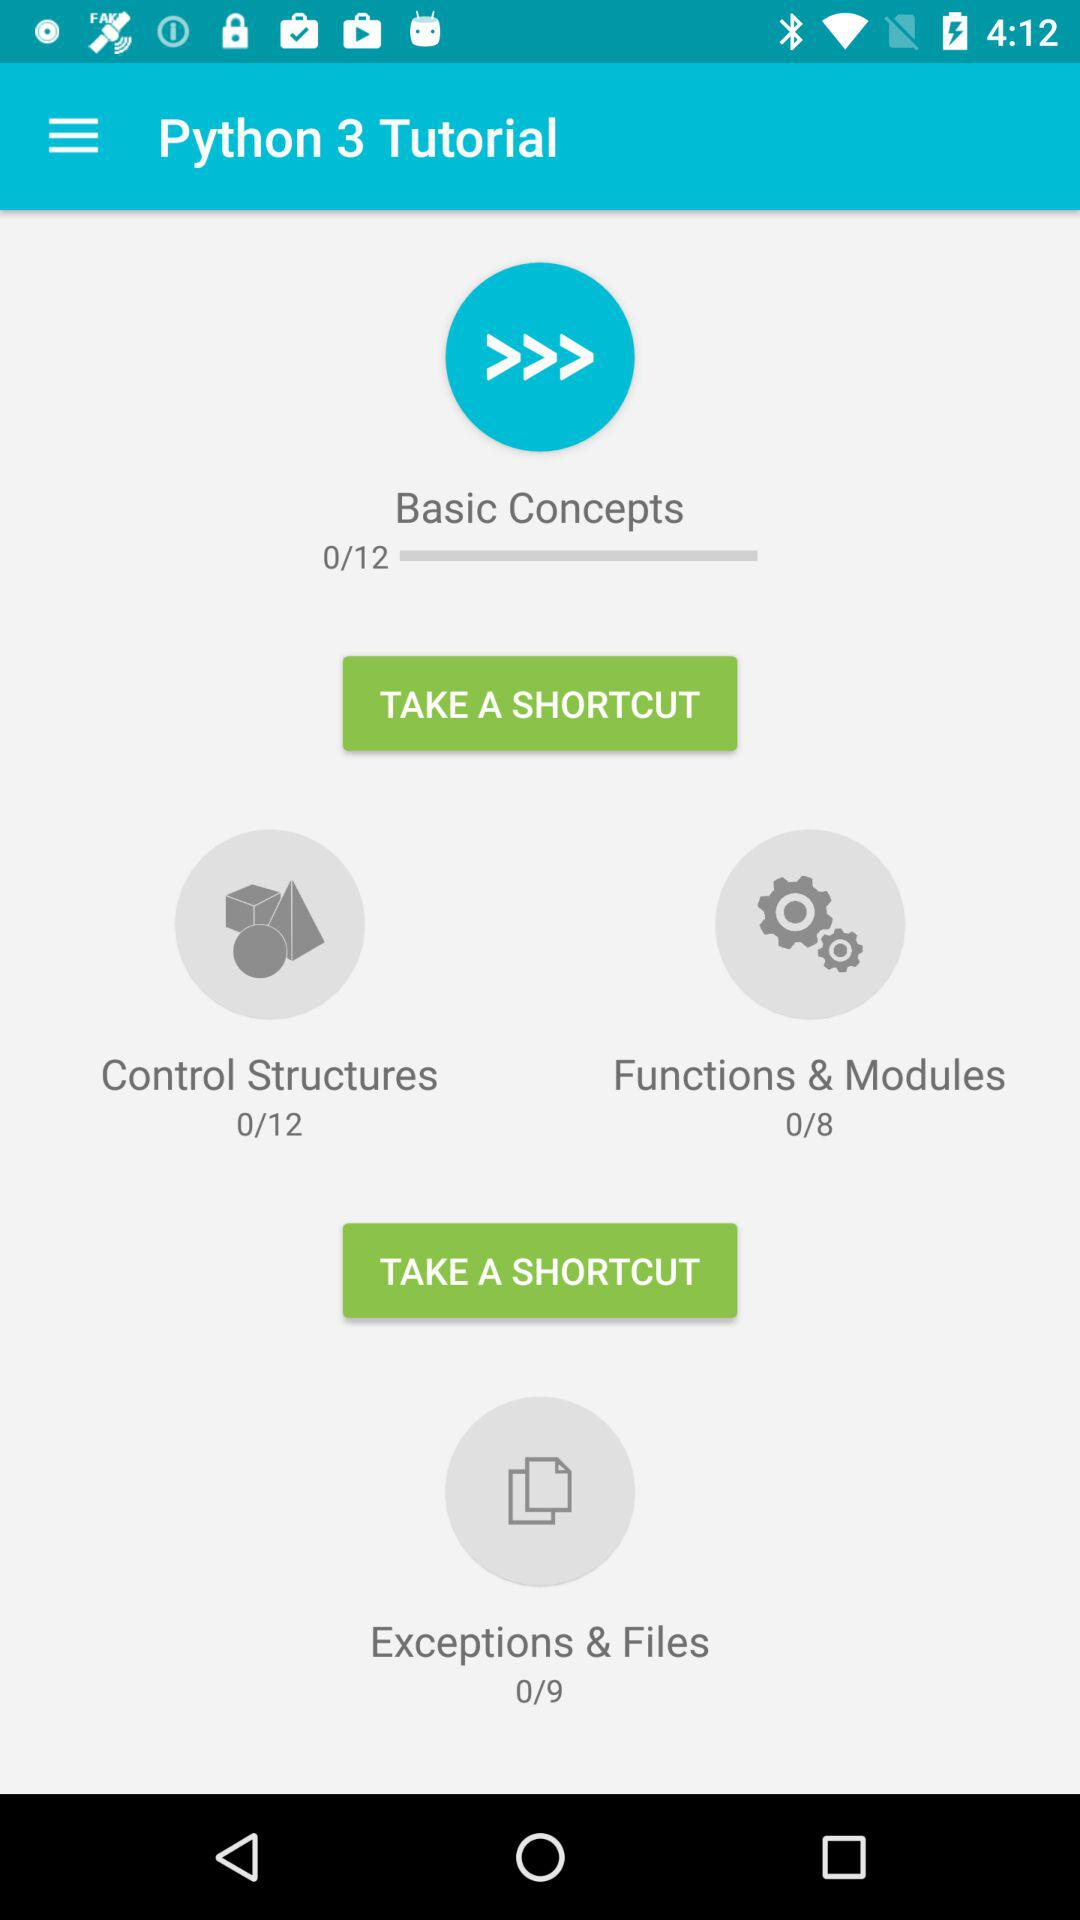What is the total number of lectures in "Basic Concepts"? The total number of lectures in "Basic Concepts" is 12. 